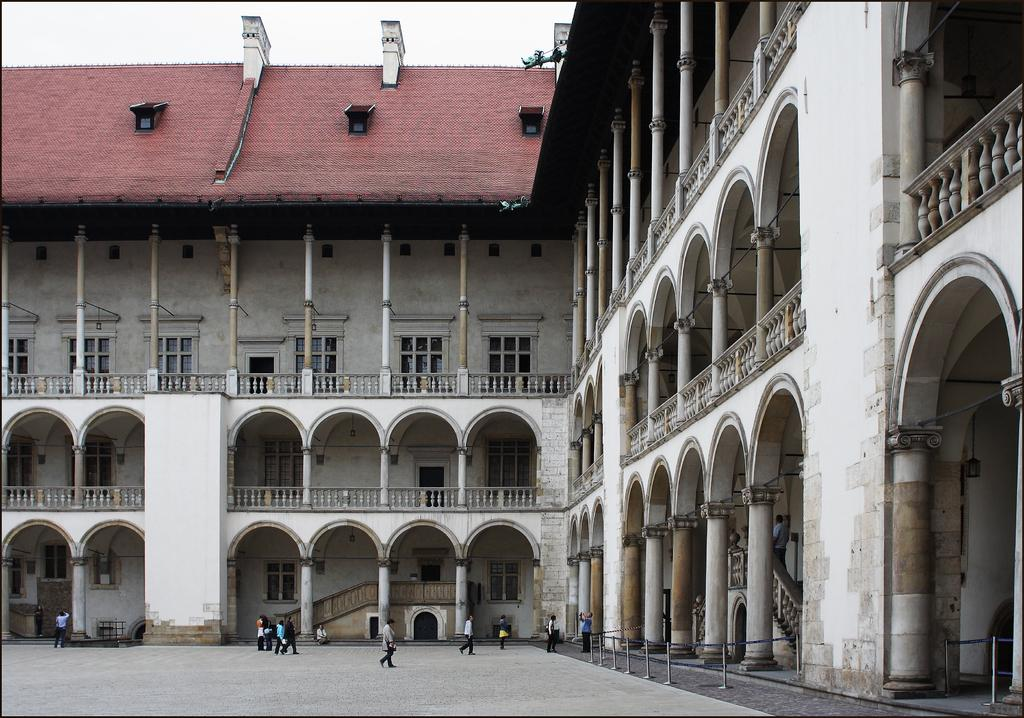What is the main structure in the image? There is a building in the image. Are there any people near the building? Yes, there are persons in front of the building. What can be seen at the top of the image? The sky is visible at the top of the image. What day of the week is it in the image? The day of the week cannot be determined from the image. Can you see a plane flying in the sky in the image? There is no plane visible in the sky in the image. 